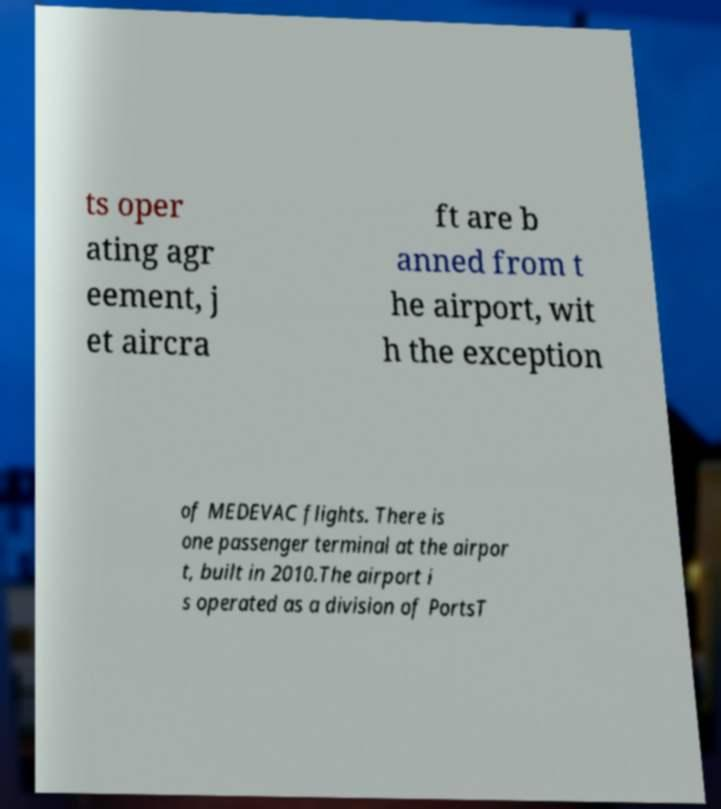Could you assist in decoding the text presented in this image and type it out clearly? ts oper ating agr eement, j et aircra ft are b anned from t he airport, wit h the exception of MEDEVAC flights. There is one passenger terminal at the airpor t, built in 2010.The airport i s operated as a division of PortsT 